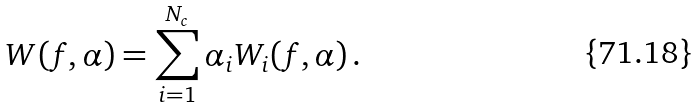<formula> <loc_0><loc_0><loc_500><loc_500>W ( f , \alpha ) = \sum _ { i = 1 } ^ { N _ { c } } \alpha _ { i } W _ { i } ( f , \alpha ) \, .</formula> 